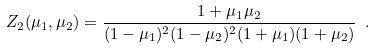Convert formula to latex. <formula><loc_0><loc_0><loc_500><loc_500>Z _ { 2 } ( \mu _ { 1 } , \mu _ { 2 } ) = \frac { 1 + \mu _ { 1 } \mu _ { 2 } } { ( 1 - \mu _ { 1 } ) ^ { 2 } ( 1 - \mu _ { 2 } ) ^ { 2 } ( 1 + \mu _ { 1 } ) ( 1 + \mu _ { 2 } ) } \ .</formula> 